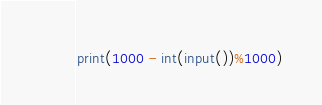<code> <loc_0><loc_0><loc_500><loc_500><_Python_>print(1000 - int(input())%1000)</code> 